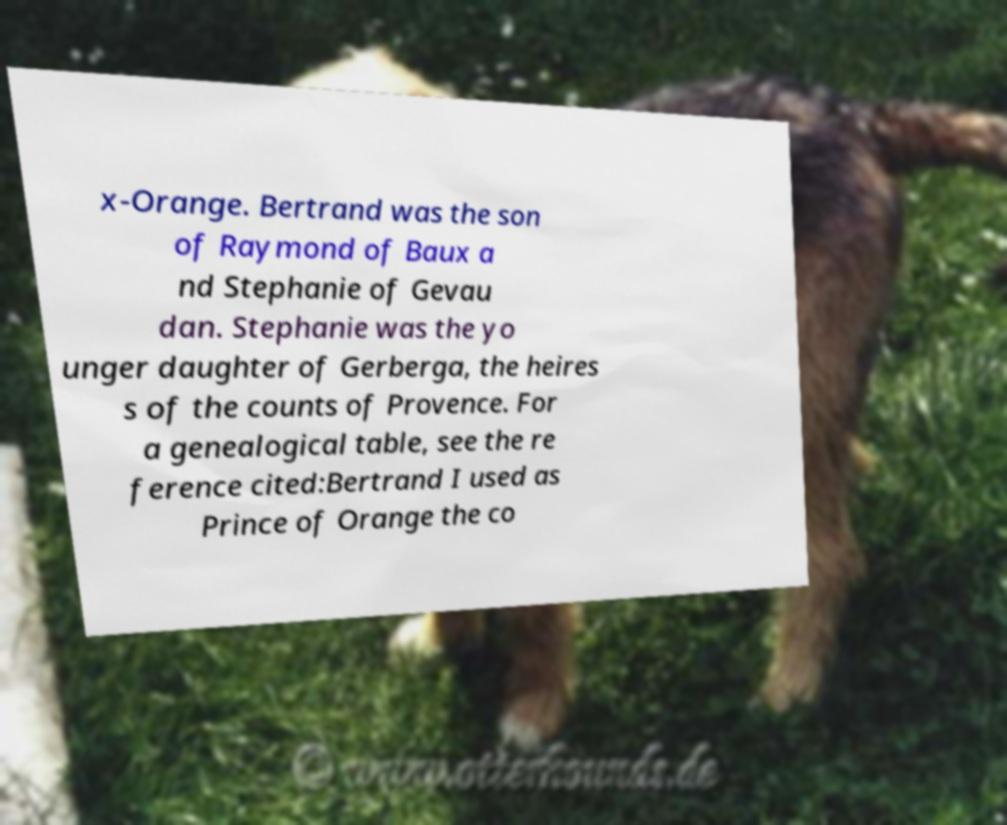I need the written content from this picture converted into text. Can you do that? x-Orange. Bertrand was the son of Raymond of Baux a nd Stephanie of Gevau dan. Stephanie was the yo unger daughter of Gerberga, the heires s of the counts of Provence. For a genealogical table, see the re ference cited:Bertrand I used as Prince of Orange the co 